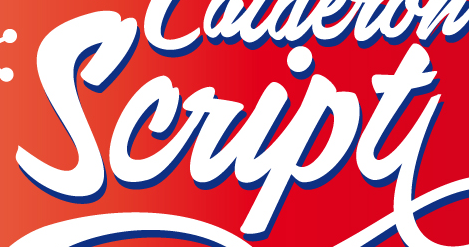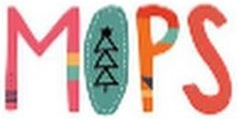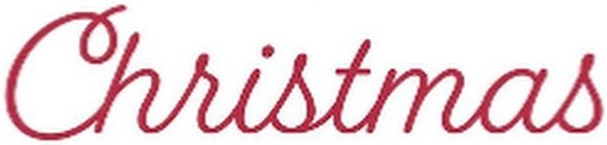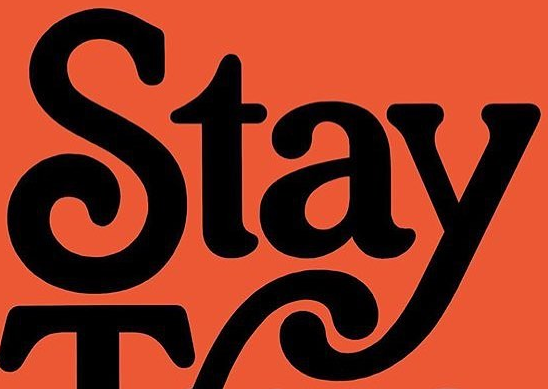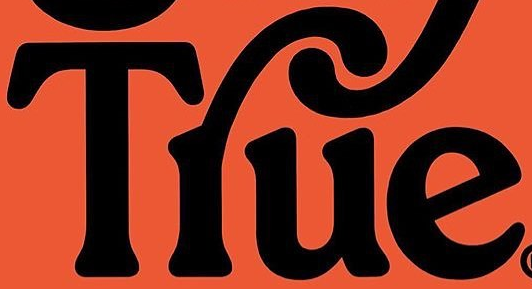Read the text content from these images in order, separated by a semicolon. Script; MOPS; Christmas; Stay; Tlue 